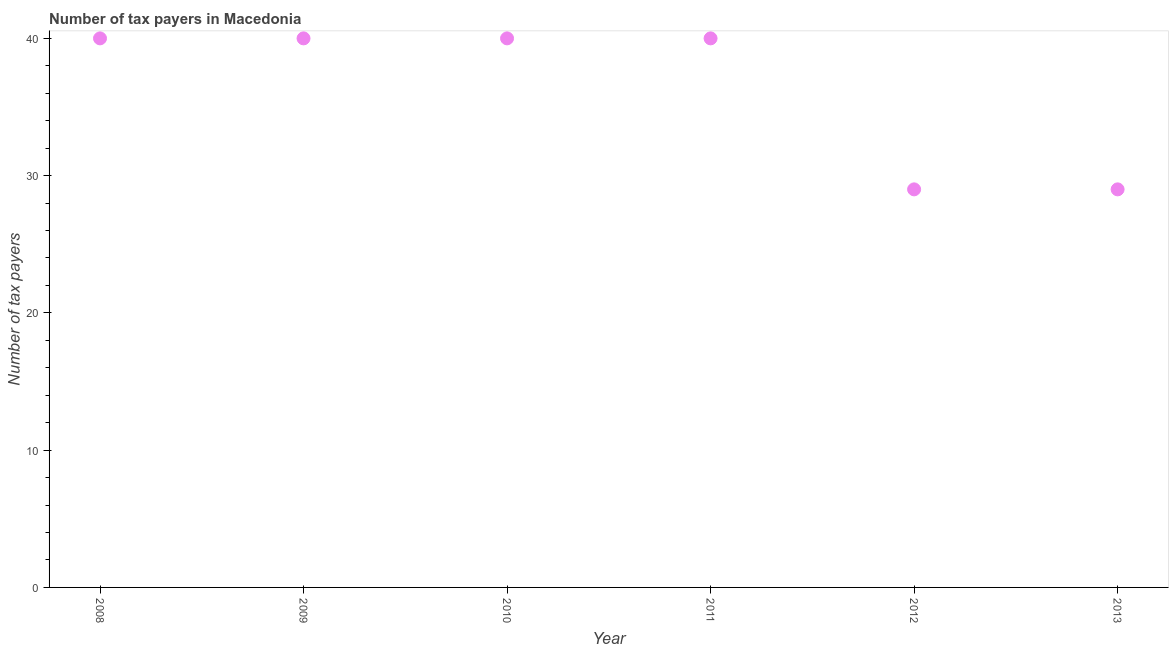What is the number of tax payers in 2008?
Provide a short and direct response. 40. Across all years, what is the maximum number of tax payers?
Offer a terse response. 40. Across all years, what is the minimum number of tax payers?
Offer a very short reply. 29. What is the sum of the number of tax payers?
Give a very brief answer. 218. What is the difference between the number of tax payers in 2011 and 2013?
Give a very brief answer. 11. What is the average number of tax payers per year?
Your answer should be compact. 36.33. Do a majority of the years between 2009 and 2010 (inclusive) have number of tax payers greater than 28 ?
Ensure brevity in your answer.  Yes. What is the ratio of the number of tax payers in 2010 to that in 2012?
Your answer should be compact. 1.38. Is the number of tax payers in 2008 less than that in 2009?
Make the answer very short. No. Is the sum of the number of tax payers in 2010 and 2013 greater than the maximum number of tax payers across all years?
Give a very brief answer. Yes. What is the difference between the highest and the lowest number of tax payers?
Ensure brevity in your answer.  11. Does the graph contain any zero values?
Provide a short and direct response. No. Does the graph contain grids?
Give a very brief answer. No. What is the title of the graph?
Keep it short and to the point. Number of tax payers in Macedonia. What is the label or title of the X-axis?
Offer a terse response. Year. What is the label or title of the Y-axis?
Make the answer very short. Number of tax payers. What is the Number of tax payers in 2008?
Provide a short and direct response. 40. What is the Number of tax payers in 2009?
Ensure brevity in your answer.  40. What is the Number of tax payers in 2011?
Your answer should be compact. 40. What is the Number of tax payers in 2012?
Your answer should be very brief. 29. What is the difference between the Number of tax payers in 2008 and 2011?
Your answer should be compact. 0. What is the difference between the Number of tax payers in 2010 and 2011?
Ensure brevity in your answer.  0. What is the difference between the Number of tax payers in 2010 and 2013?
Provide a succinct answer. 11. What is the ratio of the Number of tax payers in 2008 to that in 2010?
Make the answer very short. 1. What is the ratio of the Number of tax payers in 2008 to that in 2012?
Your answer should be very brief. 1.38. What is the ratio of the Number of tax payers in 2008 to that in 2013?
Your answer should be very brief. 1.38. What is the ratio of the Number of tax payers in 2009 to that in 2012?
Provide a succinct answer. 1.38. What is the ratio of the Number of tax payers in 2009 to that in 2013?
Your answer should be compact. 1.38. What is the ratio of the Number of tax payers in 2010 to that in 2011?
Your answer should be compact. 1. What is the ratio of the Number of tax payers in 2010 to that in 2012?
Ensure brevity in your answer.  1.38. What is the ratio of the Number of tax payers in 2010 to that in 2013?
Provide a succinct answer. 1.38. What is the ratio of the Number of tax payers in 2011 to that in 2012?
Give a very brief answer. 1.38. What is the ratio of the Number of tax payers in 2011 to that in 2013?
Your answer should be very brief. 1.38. 